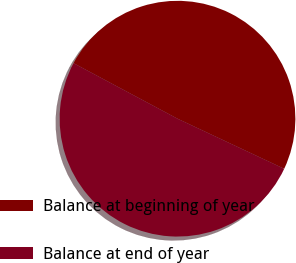<chart> <loc_0><loc_0><loc_500><loc_500><pie_chart><fcel>Balance at beginning of year<fcel>Balance at end of year<nl><fcel>49.18%<fcel>50.82%<nl></chart> 